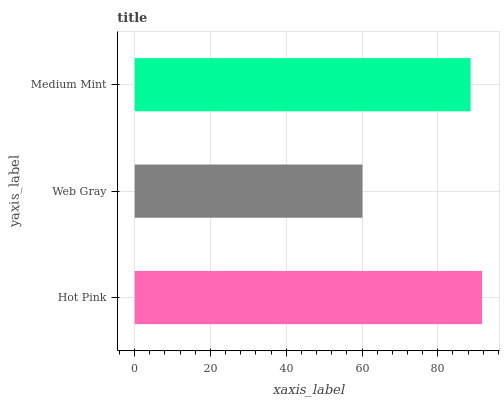Is Web Gray the minimum?
Answer yes or no. Yes. Is Hot Pink the maximum?
Answer yes or no. Yes. Is Medium Mint the minimum?
Answer yes or no. No. Is Medium Mint the maximum?
Answer yes or no. No. Is Medium Mint greater than Web Gray?
Answer yes or no. Yes. Is Web Gray less than Medium Mint?
Answer yes or no. Yes. Is Web Gray greater than Medium Mint?
Answer yes or no. No. Is Medium Mint less than Web Gray?
Answer yes or no. No. Is Medium Mint the high median?
Answer yes or no. Yes. Is Medium Mint the low median?
Answer yes or no. Yes. Is Web Gray the high median?
Answer yes or no. No. Is Web Gray the low median?
Answer yes or no. No. 